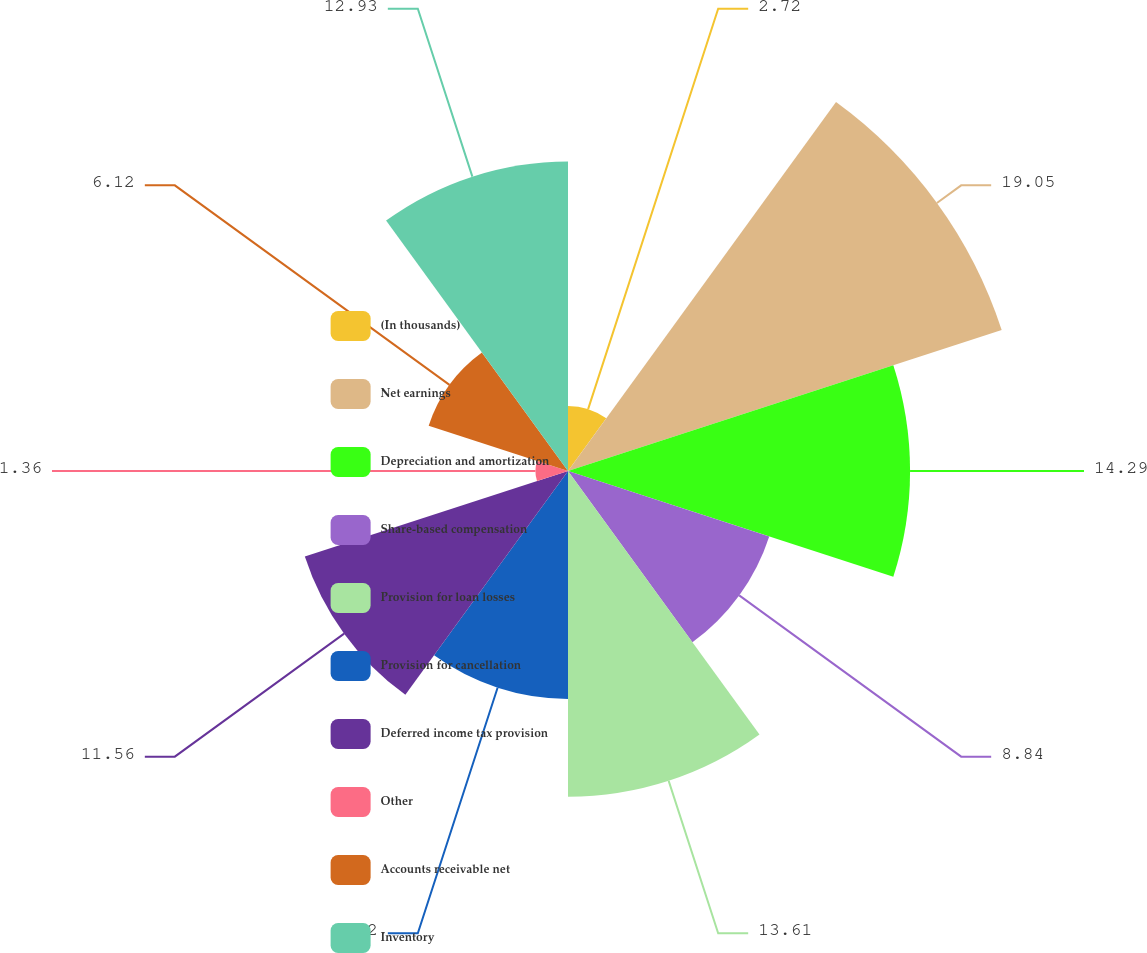<chart> <loc_0><loc_0><loc_500><loc_500><pie_chart><fcel>(In thousands)<fcel>Net earnings<fcel>Depreciation and amortization<fcel>Share-based compensation<fcel>Provision for loan losses<fcel>Provision for cancellation<fcel>Deferred income tax provision<fcel>Other<fcel>Accounts receivable net<fcel>Inventory<nl><fcel>2.72%<fcel>19.05%<fcel>14.29%<fcel>8.84%<fcel>13.61%<fcel>9.52%<fcel>11.56%<fcel>1.36%<fcel>6.12%<fcel>12.93%<nl></chart> 